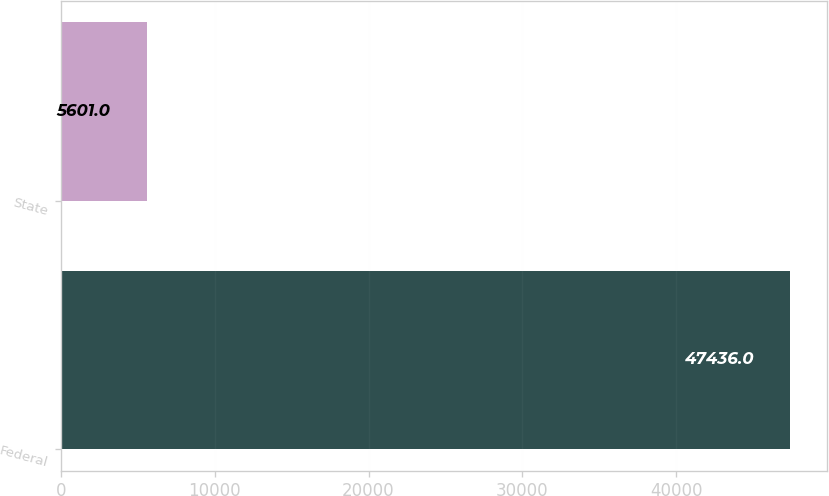Convert chart to OTSL. <chart><loc_0><loc_0><loc_500><loc_500><bar_chart><fcel>Federal<fcel>State<nl><fcel>47436<fcel>5601<nl></chart> 